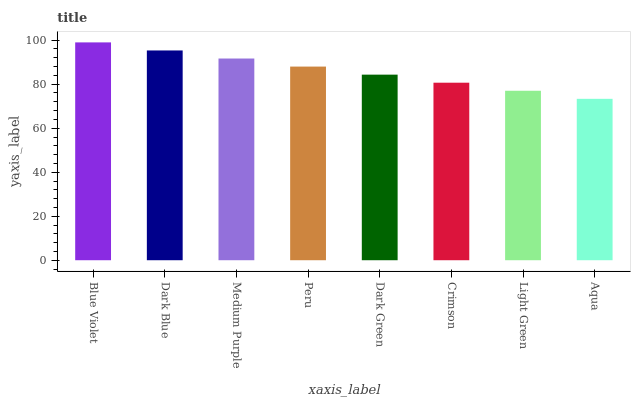Is Aqua the minimum?
Answer yes or no. Yes. Is Blue Violet the maximum?
Answer yes or no. Yes. Is Dark Blue the minimum?
Answer yes or no. No. Is Dark Blue the maximum?
Answer yes or no. No. Is Blue Violet greater than Dark Blue?
Answer yes or no. Yes. Is Dark Blue less than Blue Violet?
Answer yes or no. Yes. Is Dark Blue greater than Blue Violet?
Answer yes or no. No. Is Blue Violet less than Dark Blue?
Answer yes or no. No. Is Peru the high median?
Answer yes or no. Yes. Is Dark Green the low median?
Answer yes or no. Yes. Is Blue Violet the high median?
Answer yes or no. No. Is Aqua the low median?
Answer yes or no. No. 